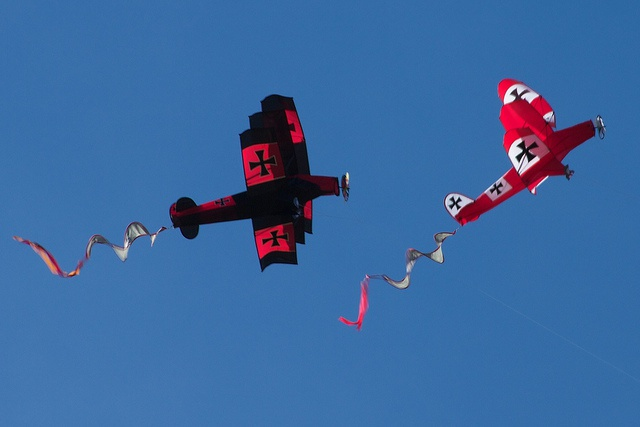Describe the objects in this image and their specific colors. I can see kite in gray, black, and maroon tones and kite in gray, maroon, brown, and lavender tones in this image. 